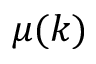Convert formula to latex. <formula><loc_0><loc_0><loc_500><loc_500>\mu ( k )</formula> 